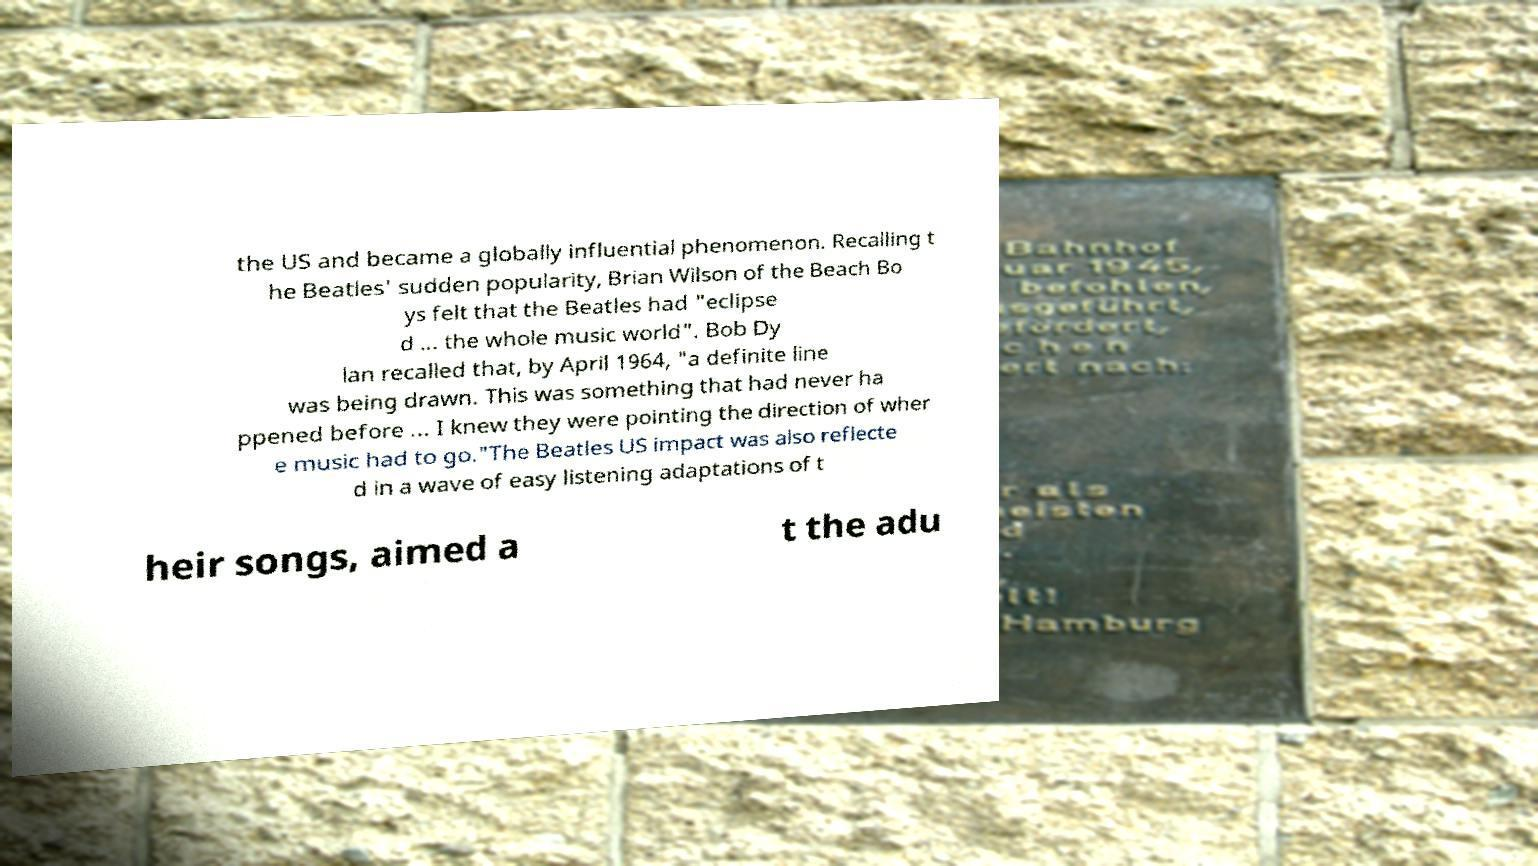I need the written content from this picture converted into text. Can you do that? the US and became a globally influential phenomenon. Recalling t he Beatles' sudden popularity, Brian Wilson of the Beach Bo ys felt that the Beatles had "eclipse d ... the whole music world". Bob Dy lan recalled that, by April 1964, "a definite line was being drawn. This was something that had never ha ppened before ... I knew they were pointing the direction of wher e music had to go."The Beatles US impact was also reflecte d in a wave of easy listening adaptations of t heir songs, aimed a t the adu 